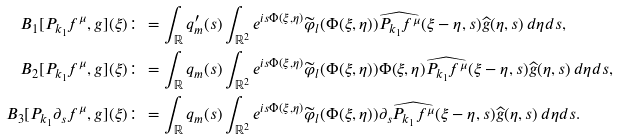<formula> <loc_0><loc_0><loc_500><loc_500>B _ { 1 } [ P _ { k _ { 1 } } f ^ { \mu } , g ] ( \xi ) & \colon = \int _ { \mathbb { R } } q ^ { \prime } _ { m } ( s ) \int _ { \mathbb { R } ^ { 2 } } e ^ { i s \Phi ( \xi , \eta ) } \widetilde { \varphi } _ { l } ( \Phi ( \xi , \eta ) ) \widehat { P _ { k _ { 1 } } f ^ { \mu } } ( \xi - \eta , s ) \widehat { g } ( \eta , s ) \, d \eta d s , \\ B _ { 2 } [ P _ { k _ { 1 } } f ^ { \mu } , g ] ( \xi ) & \colon = \int _ { \mathbb { R } } q _ { m } ( s ) \int _ { \mathbb { R } ^ { 2 } } e ^ { i s \Phi ( \xi , \eta ) } \widetilde { \varphi } _ { l } ( \Phi ( \xi , \eta ) ) \Phi ( \xi , \eta ) \widehat { P _ { k _ { 1 } } f ^ { \mu } } ( \xi - \eta , s ) \widehat { g } ( \eta , s ) \, d \eta d s , \\ B _ { 3 } [ P _ { k _ { 1 } } \partial _ { s } f ^ { \mu } , g ] ( \xi ) & \colon = \int _ { \mathbb { R } } q _ { m } ( s ) \int _ { \mathbb { R } ^ { 2 } } e ^ { i s \Phi ( \xi , \eta ) } \widetilde { \varphi } _ { l } ( \Phi ( \xi , \eta ) ) \partial _ { s } \widehat { P _ { k _ { 1 } } f ^ { \mu } } ( \xi - \eta , s ) \widehat { g } ( \eta , s ) \, d \eta d s .</formula> 